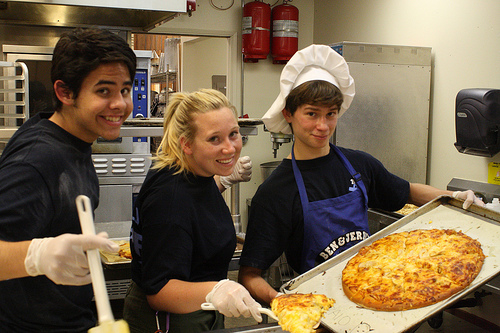How many people are in this picture? There are 3 people in the picture, all of them appear to be happily engaged in a cooking activity, likely in a professional kitchen setting. 